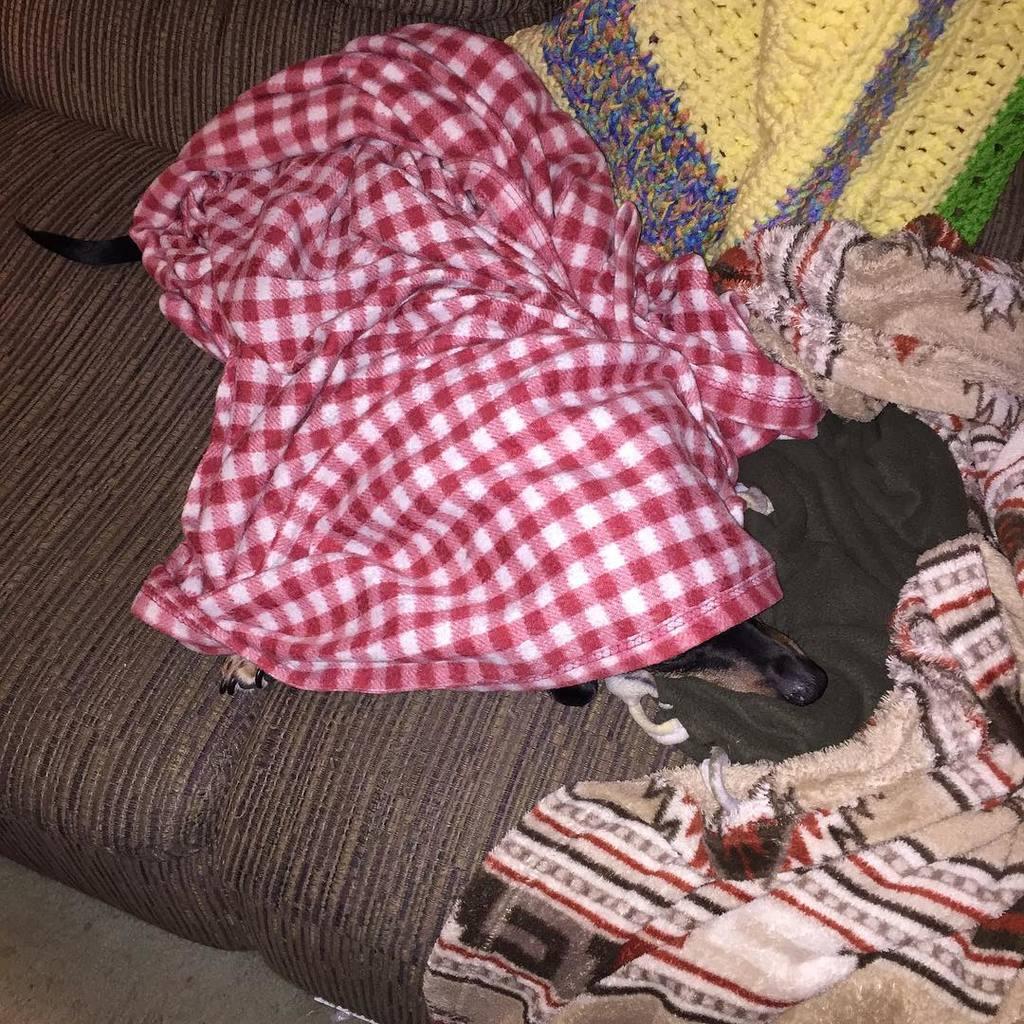In one or two sentences, can you explain what this image depicts? In this image we can see there are some bed sheets, under the bed sheet there is a dog, sleeping on the sofa. 